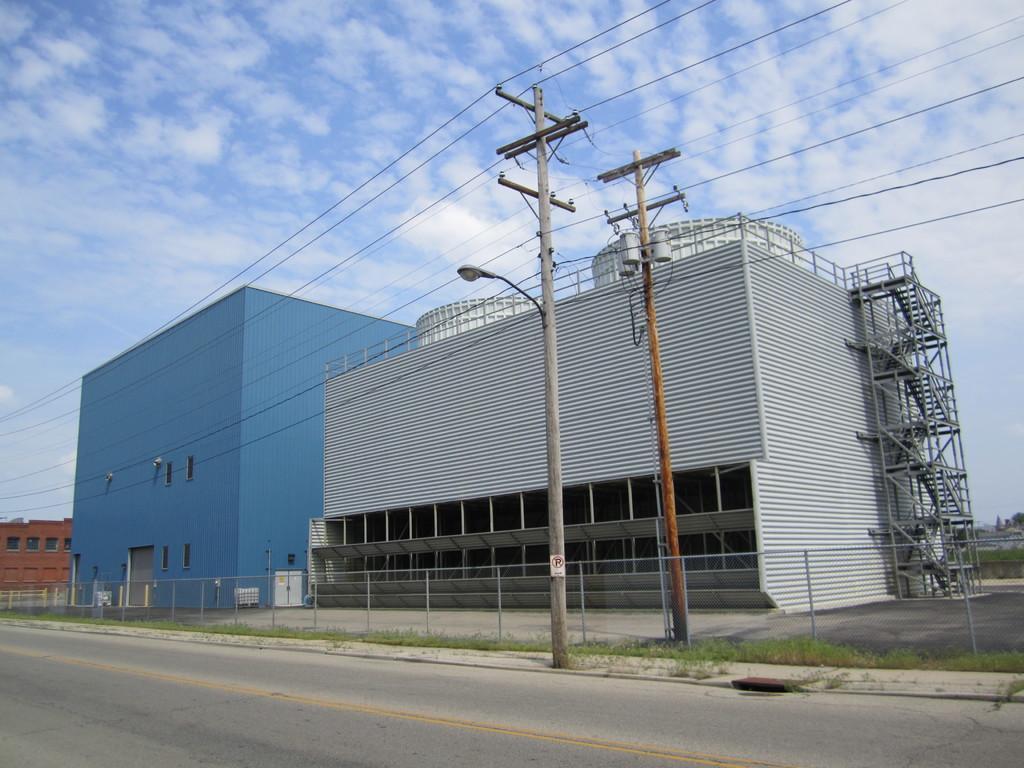How would you summarize this image in a sentence or two? In this image, we can see buildings and poles. There is a fence beside the road. There are clouds in the sky. 